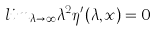Convert formula to latex. <formula><loc_0><loc_0><loc_500><loc_500>l i m _ { \lambda \rightarrow \infty } \lambda ^ { 2 } \eta ^ { \prime } ( \lambda , x ) = 0</formula> 